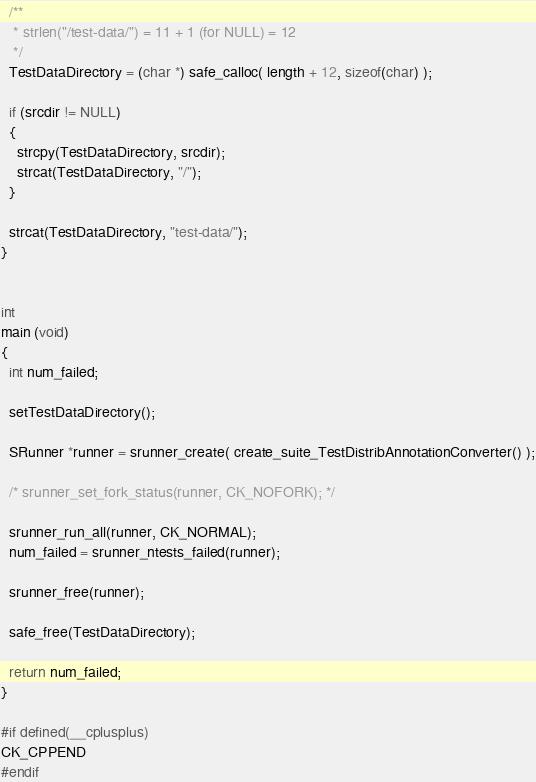<code> <loc_0><loc_0><loc_500><loc_500><_C++_>
  /**
   * strlen("/test-data/") = 11 + 1 (for NULL) = 12
   */
  TestDataDirectory = (char *) safe_calloc( length + 12, sizeof(char) );

  if (srcdir != NULL)
  {
    strcpy(TestDataDirectory, srcdir);
    strcat(TestDataDirectory, "/");
  }

  strcat(TestDataDirectory, "test-data/");
}


int
main (void) 
{ 
  int num_failed;

  setTestDataDirectory();

  SRunner *runner = srunner_create( create_suite_TestDistribAnnotationConverter() );

  /* srunner_set_fork_status(runner, CK_NOFORK); */

  srunner_run_all(runner, CK_NORMAL);
  num_failed = srunner_ntests_failed(runner);

  srunner_free(runner);
  
  safe_free(TestDataDirectory);

  return num_failed;
}

#if defined(__cplusplus)
CK_CPPEND
#endif


</code> 